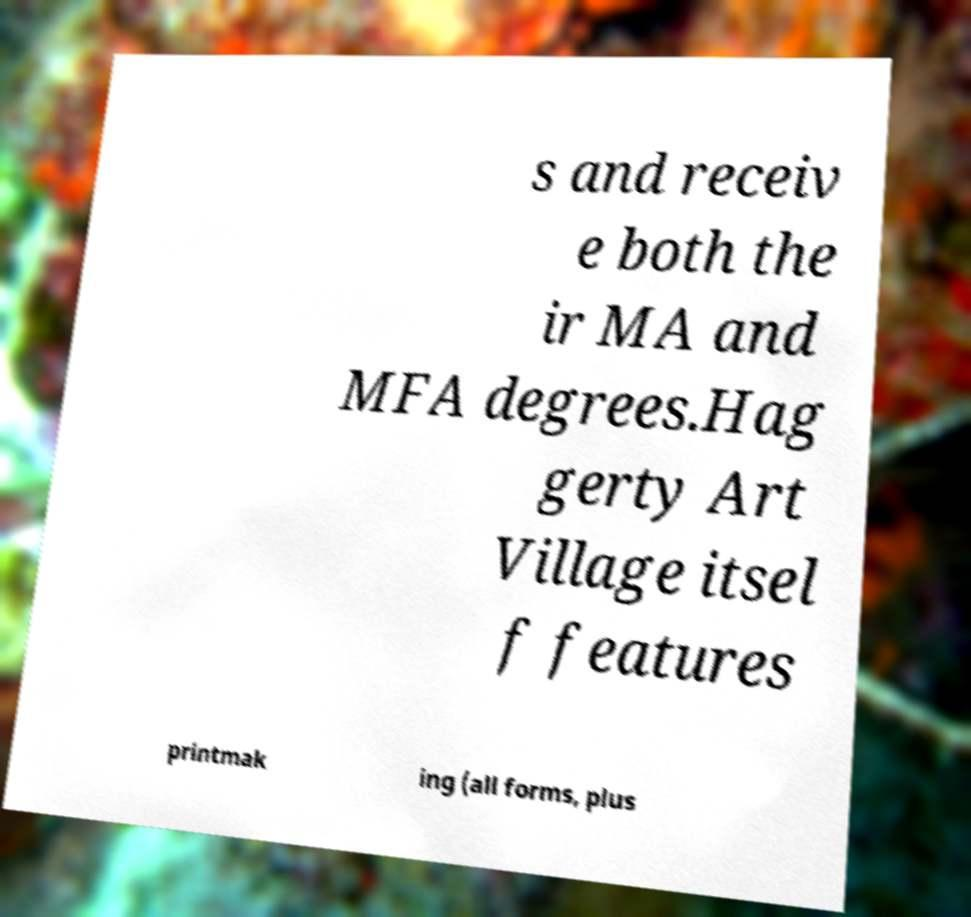For documentation purposes, I need the text within this image transcribed. Could you provide that? s and receiv e both the ir MA and MFA degrees.Hag gerty Art Village itsel f features printmak ing (all forms, plus 